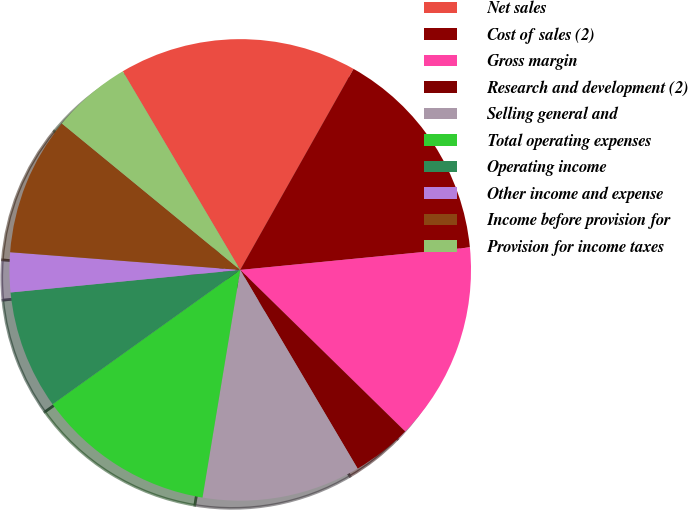Convert chart. <chart><loc_0><loc_0><loc_500><loc_500><pie_chart><fcel>Net sales<fcel>Cost of sales (2)<fcel>Gross margin<fcel>Research and development (2)<fcel>Selling general and<fcel>Total operating expenses<fcel>Operating income<fcel>Other income and expense<fcel>Income before provision for<fcel>Provision for income taxes<nl><fcel>16.67%<fcel>15.28%<fcel>13.89%<fcel>4.17%<fcel>11.11%<fcel>12.5%<fcel>8.33%<fcel>2.78%<fcel>9.72%<fcel>5.56%<nl></chart> 